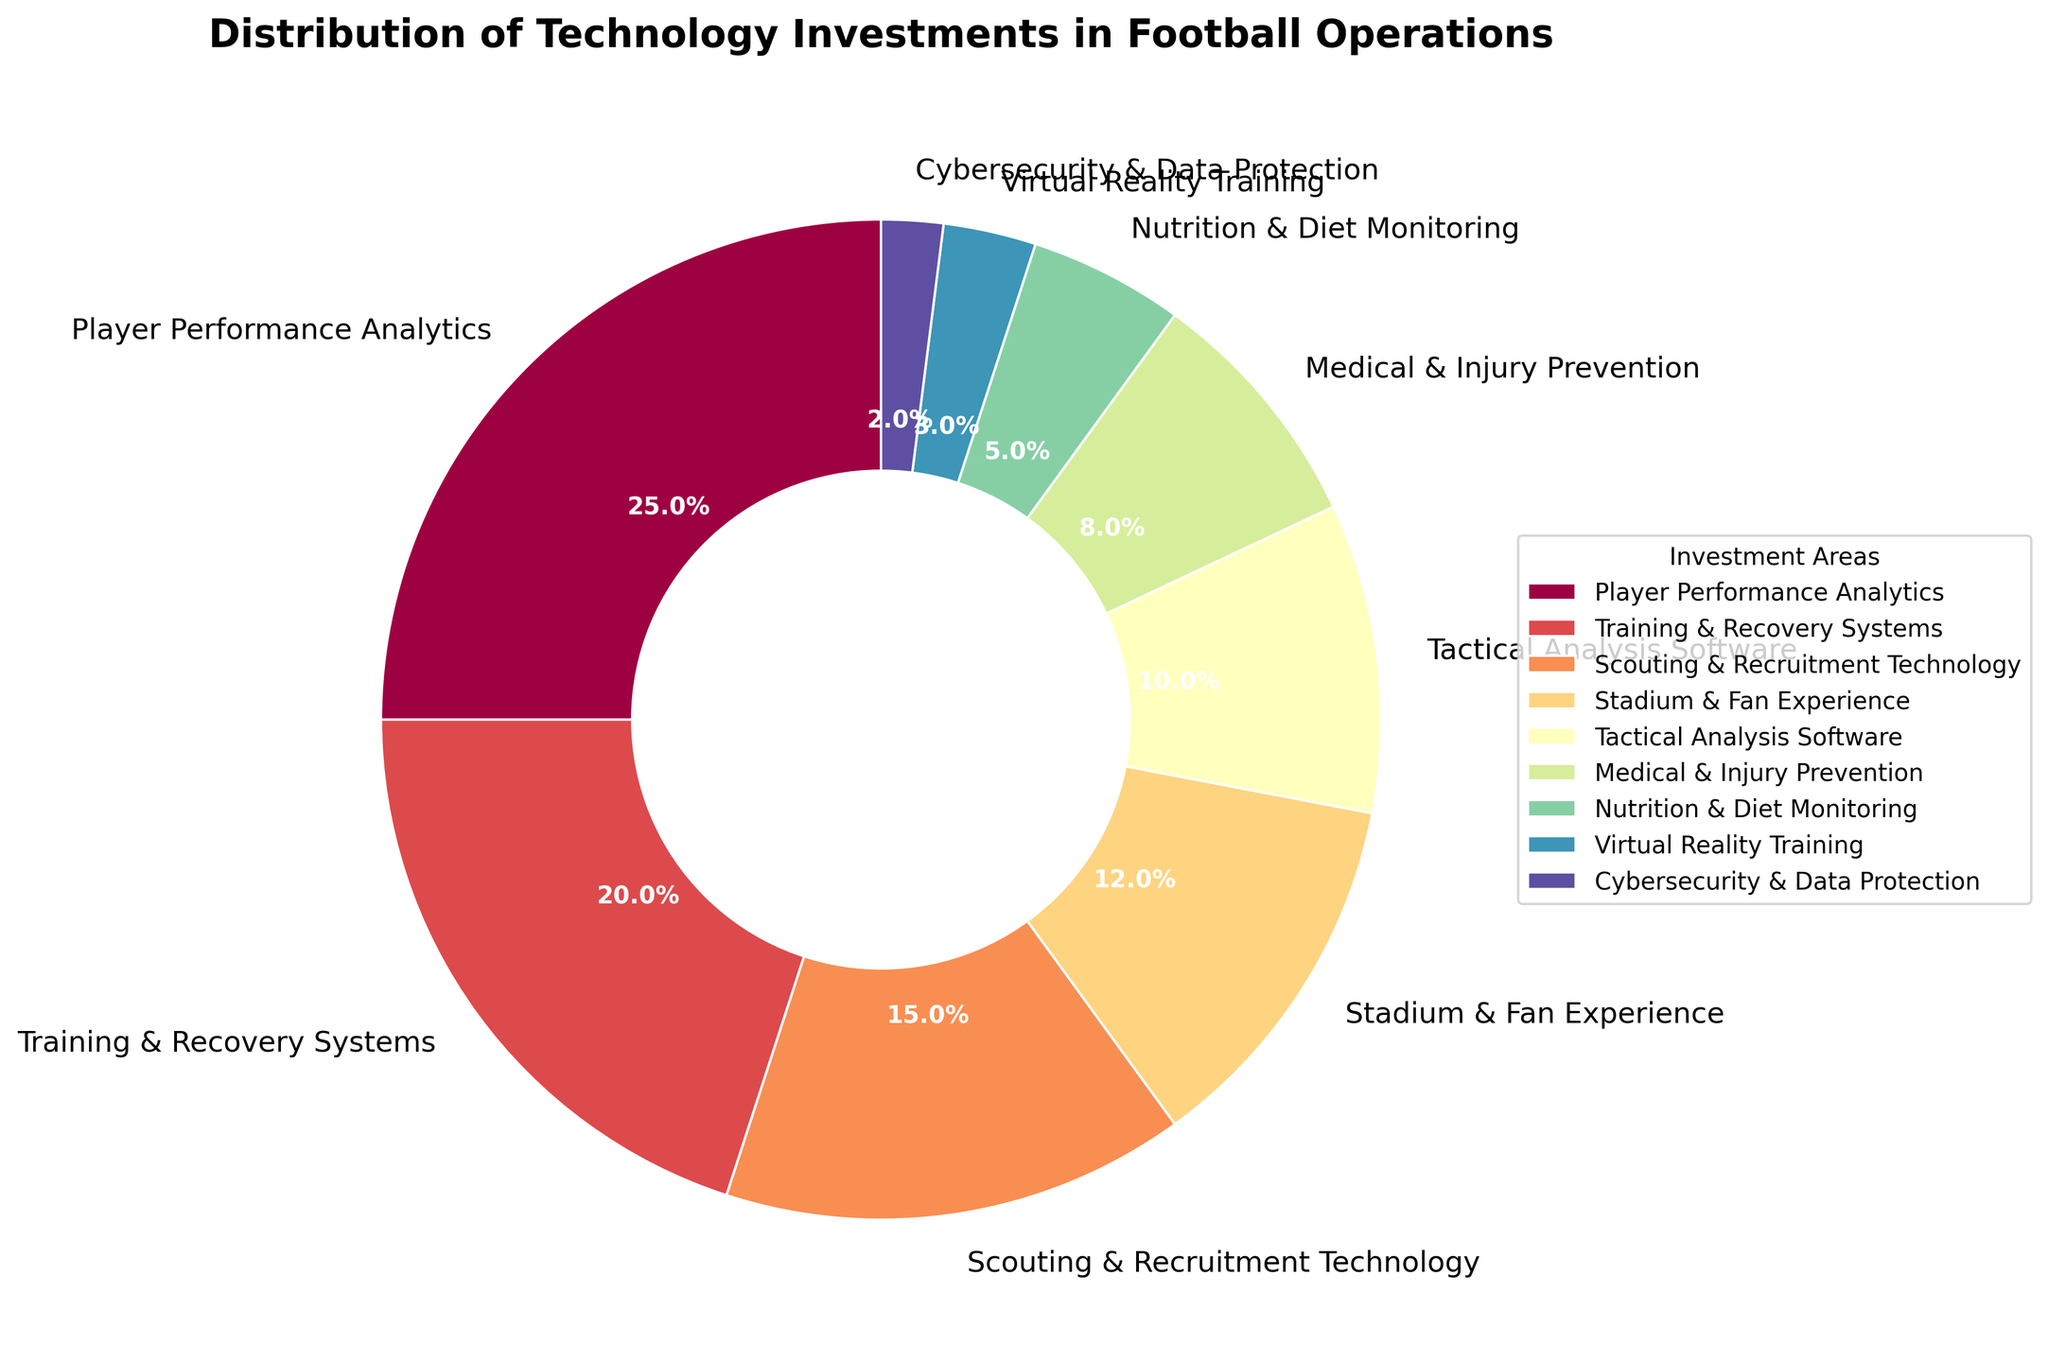Which area receives the highest percentage of technology investment? To find the area with the highest investment, look for the largest sector in the pie chart. The largest sector is labeled as Player Performance Analytics with 25%.
Answer: Player Performance Analytics What is the total percentage of investments in Training & Recovery Systems and Scouting & Recruitment Technology combined? Add the percentages of Training & Recovery Systems (20%) and Scouting & Recruitment Technology (15%). The sum is 20 + 15 = 35%.
Answer: 35% Which area gets less investment: Nutrition & Diet Monitoring or Virtual Reality Training? Compare the percentages of Nutrition & Diet Monitoring (5%) and Virtual Reality Training (3%). Since 3% is less than 5%, Virtual Reality Training receives less investment.
Answer: Virtual Reality Training How much more investment does Tactical Analysis Software get than Cybersecurity & Data Protection? Subtract the percentage of Cybersecurity & Data Protection (2%) from Tactical Analysis Software (10%). The difference is 10 - 2 = 8%.
Answer: 8% What is the combined percentage of investment in Stadium & Fan Experience and Medical & Injury Prevention? Add the percentages of Stadium & Fan Experience (12%) and Medical & Injury Prevention (8%). The sum is 12 + 8 = 20%.
Answer: 20% Which investment area is represented by the smallest wedge in terms of percentage? Find the smallest sector in the pie chart. The smallest sector is Cybersecurity & Data Protection with 2%.
Answer: Cybersecurity & Data Protection What is the difference in investment between the two largest areas? The two largest areas are Player Performance Analytics (25%) and Training & Recovery Systems (20%). Subtract the smaller from the larger: 25 - 20 = 5%.
Answer: 5% In terms of visual size, how does the Training & Recovery Systems sector compare to the Medical & Injury Prevention sector? Observe the pie chart sectors; Training & Recovery Systems (20%) is larger than Medical & Injury Prevention (8%). Compare the visual sizes, where 20% sector appears larger.
Answer: Training & Recovery Systems is larger What is the median value of the technology investment percentages? Assemble and sort the percentages: [2, 3, 5, 8, 10, 12, 15, 20, 25]. The middle value (5th value) in the sorted list is 10%.
Answer: 10% Which area, if any, has an investment percentage equal to the average percentage of all areas? Calculate the average percentage by summing all percentages (25+20+15+12+10+8+5+3+2=100) and dividing by the number of areas (9). The average is 100/9 ≈ 11.11%. Since no sector matches this exact percentage, no area has an investment equal to the average.
Answer: None 